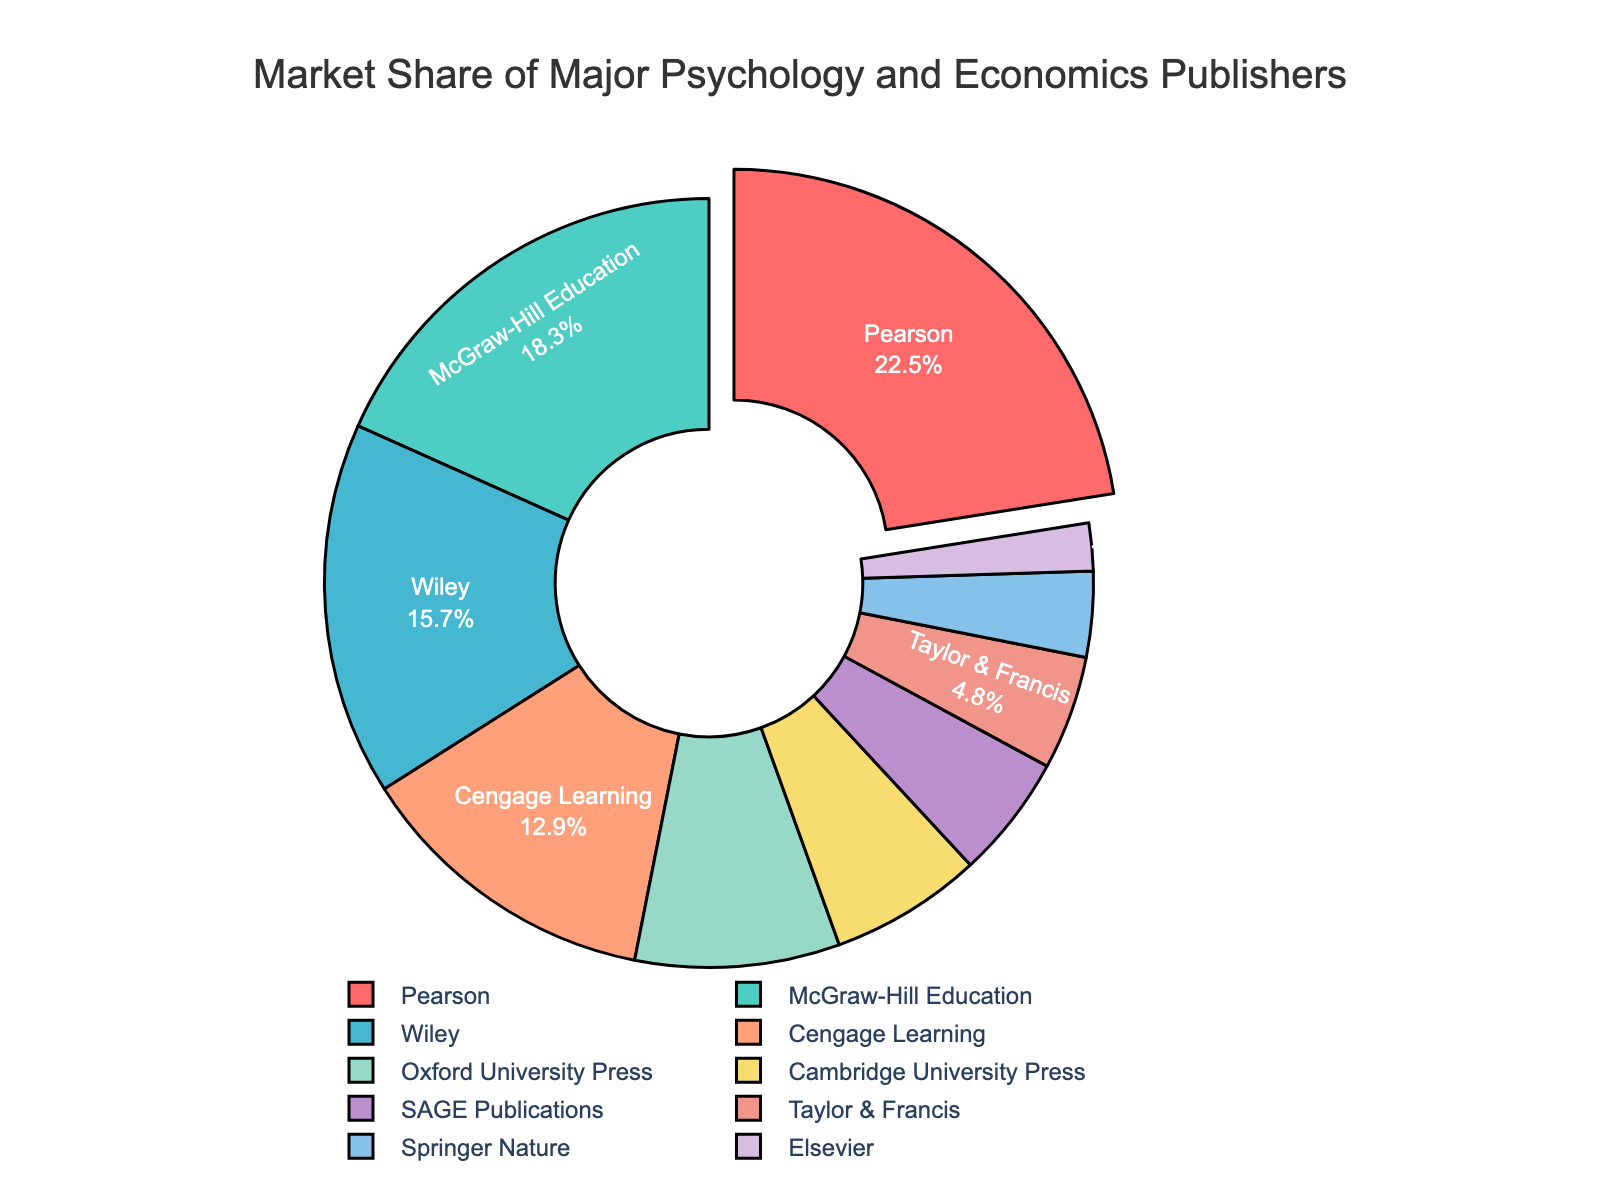Which publisher holds the largest market share? The figure shows the market shares of different publishers, with Pearson having the largest market share at 22.5%.
Answer: Pearson What is the combined market share of Pearson and McGraw-Hill Education? Pearson has a market share of 22.5% and McGraw-Hill Education has 18.3%. Adding these two shares together gives 22.5 + 18.3 = 40.8%.
Answer: 40.8% Which publishers have market shares less than 5%? The publishers with market shares less than 5% are Taylor & Francis (4.8%), Springer Nature (3.6%), and Elsevier (2%).
Answer: Taylor & Francis, Springer Nature, Elsevier Which publisher is represented in the segment pulled slightly away from the pie? The figure shows a segment slightly separated from the rest of the pie, which corresponds to Pearson.
Answer: Pearson How does the market share of Wiley compare to that of Cengage Learning? Wiley has a market share of 15.7% while Cengage Learning has 12.9%. Wiley's share is larger than Cengage Learning's by 15.7 - 12.9 = 2.8%.
Answer: Wiley has a 2.8% larger share than Cengage Learning What is the average market share of the publishers listed in the chart? The total market share is the sum of all market shares: 22.5 + 18.3 + 15.7 + 12.9 + 8.6 + 6.4 + 5.2 + 4.8 + 3.6 + 2. To find the average, divide the total by the number of publishers, 10. The calculation is (100% / 10) = 10%.
Answer: 10% Which two publishers collectively have a market share closest to that of Pearson? Cengage Learning (12.9%) and Oxford University Press (8.6%) have a combined market share of 12.9 + 8.6 = 21.5%, which is closest to Pearson's 22.5%.
Answer: Cengage Learning and Oxford University Press What is the percentage difference between the market shares of Oxford University Press and Cambridge University Press? Oxford University Press has a market share of 8.6% and Cambridge University Press has 6.4%. The percentage difference is calculated as (8.6 - 6.4) / 8.6 * 100 ≈ 25.6%.
Answer: 25.6% How do the three smallest market shares compare? The three smallest market shares are those of Springer Nature (3.6%), Taylor & Francis (4.8%), and Elsevier (2%). Elsevier is the smallest, followed by Springer Nature, and then Taylor & Francis.
Answer: Elsevier < Springer Nature < Taylor & Francis 